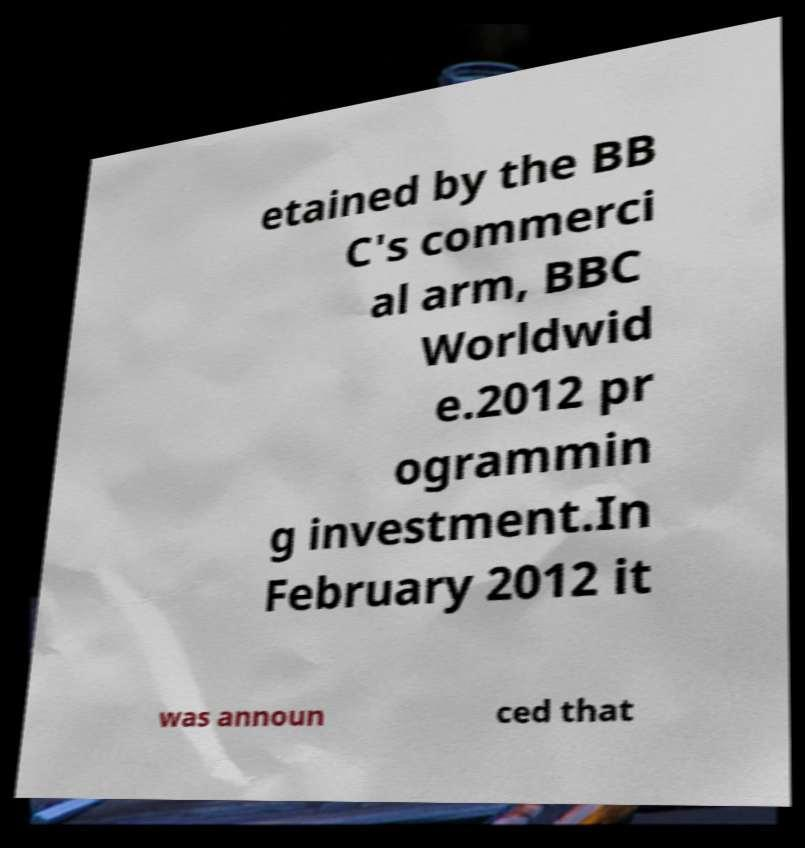Could you extract and type out the text from this image? etained by the BB C's commerci al arm, BBC Worldwid e.2012 pr ogrammin g investment.In February 2012 it was announ ced that 